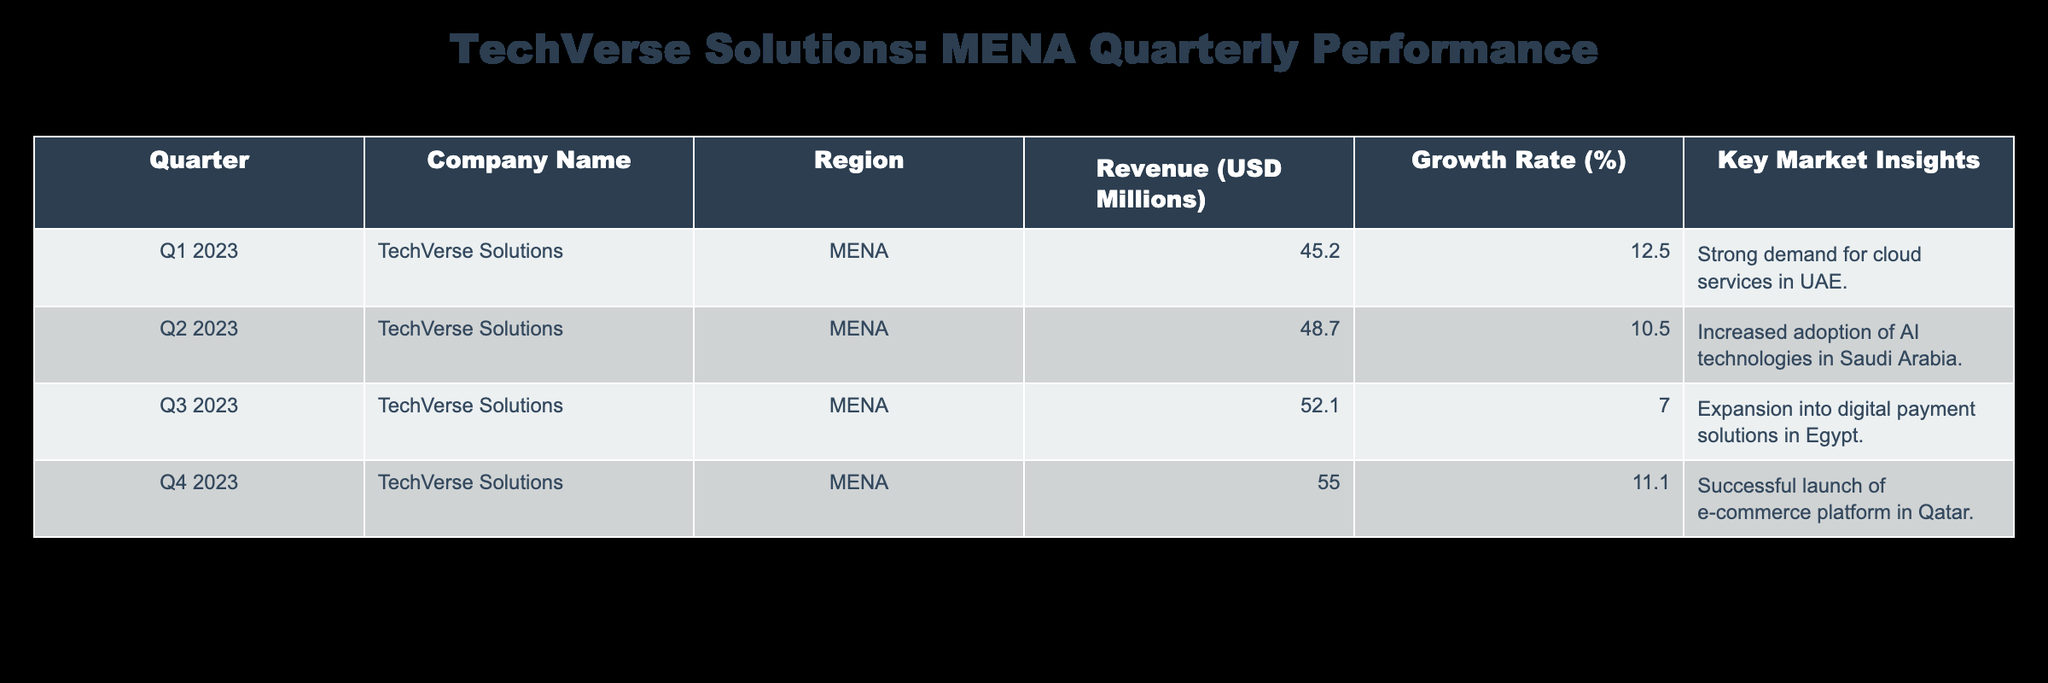What was the revenue in Q3 2023? From the table, we look at the row corresponding to Q3 2023, where the revenue for TechVerse Solutions in the MENA region is listed as 52.1 million USD.
Answer: 52.1 million USD What is the growth rate for Q1 2023? In the table, the growth rate for Q1 2023 is specified as 12.5%.
Answer: 12.5% What was the total revenue for TechVerse Solutions in the MENA region across all quarters in 2023? To find the total revenue, we add the revenues from each quarter: 45.2 + 48.7 + 52.1 + 55.0 = 201.0 million USD.
Answer: 201.0 million USD Was there an increase in revenue from Q1 to Q2 2023? To verify this, we compare the revenues of Q1 (45.2 million USD) and Q2 (48.7 million USD). Since 48.7 is greater than 45.2, there was an increase.
Answer: Yes What was the average growth rate over the four quarters? To calculate the average growth rate, we sum the growth rates for each quarter: 12.5 + 10.5 + 7.0 + 11.1 = 41.1%. Dividing by 4 gives an average growth rate of 41.1 / 4 = 10.275%.
Answer: 10.275% Did the company experience a decline in growth rate in 2023? The growth rates for each quarter are: 12.5%, 10.5%, 7.0%, and 11.1%. Neither the growth rate fell below the previous quarter continuously nor did it show an overall decline versus the highest rate, as Q4 was higher than Q3.
Answer: No Which quarter had the highest revenue growth rate? By checking the growth rates for each quarter, Q1 has 12.5%, Q2 has 10.5%, Q3 has 7.0%, and Q4 has 11.1%. The highest growth rate is in Q1 2023 at 12.5%.
Answer: Q1 2023 What key insight was reported for Q2 2023? The key market insight for Q2 2023 is "Increased adoption of AI technologies in Saudi Arabia." This is derived directly from the corresponding table entry.
Answer: Increased adoption of AI technologies in Saudi Arabia 